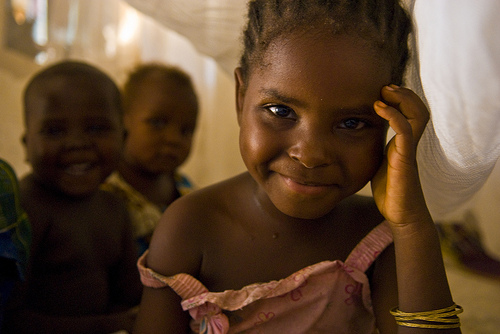<image>
Is the girl behind the boy? No. The girl is not behind the boy. From this viewpoint, the girl appears to be positioned elsewhere in the scene. Is there a child behind the other child? No. The child is not behind the other child. From this viewpoint, the child appears to be positioned elsewhere in the scene. 